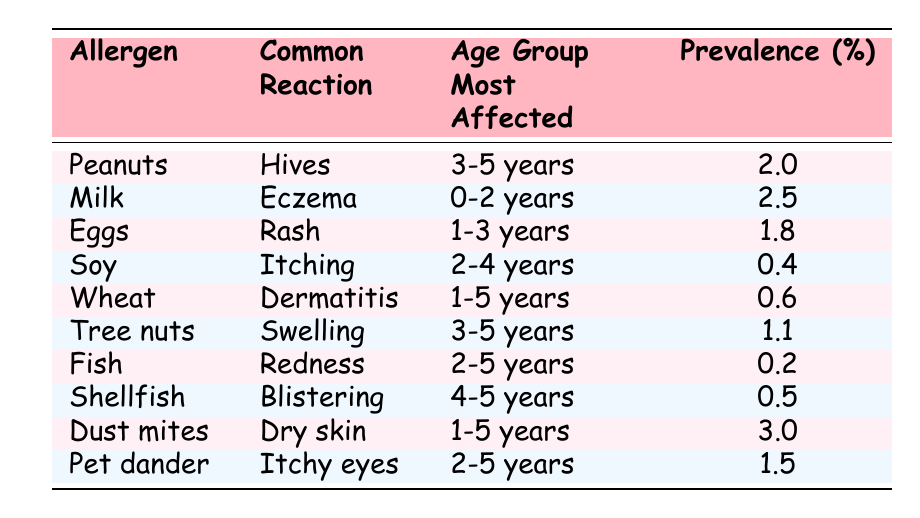What is the common reaction for milk? The table lists the allergen "Milk," and next to it, under "Common Reaction," it states "Eczema."
Answer: Eczema Which allergen has the highest prevalence? Looking through the "Prevalence (%)" column, the highest percentage is found next to "Dust mites," which is 3.0%.
Answer: Dust mites How many allergens have a prevalence of less than 1%? The allergens listed with prevalences of less than 1% are "Fish" (0.2%), "Soy" (0.4%), "Shellfish" (0.5%), and "Wheat" (0.6%). That's a total of 4 allergens.
Answer: 4 Is it true that tree nuts cause hives? In the table, the allergen "Tree nuts" is associated with the reaction "Swelling," not hives. Therefore, the statement is false.
Answer: No What is the average prevalence of allergens affecting children aged 2-5 years? The allergens affecting this age group are "Soy" (0.4%), "Fish" (0.2%), "Shellfish" (0.5%), and "Pet dander" (1.5%). Adding these gives 0.4 + 0.2 + 0.5 + 1.5 = 2.6%. Dividing by the number of allergens (4) gives an average of 2.6% / 4 = 0.65%.
Answer: 0.65% Which age group is most affected by egg allergies? The age group associated with the allergen "Eggs" is "1-3 years," indicated in the corresponding row for eggs.
Answer: 1-3 years What are the common reactions for allergens related to children aged 3-5 years? The allergens for this age group are "Peanuts" (Hives), "Tree nuts" (Swelling), and "Shellfish" (Blistering). Therefore, all common reactions are linked to these allergens.
Answer: Hives, Swelling, Blistering How many allergens are known to cause itching? Upon review, the allergen that causes itching is "Soy," noted in the Common Reaction column. Hence, there is only one allergen that causes itching.
Answer: 1 